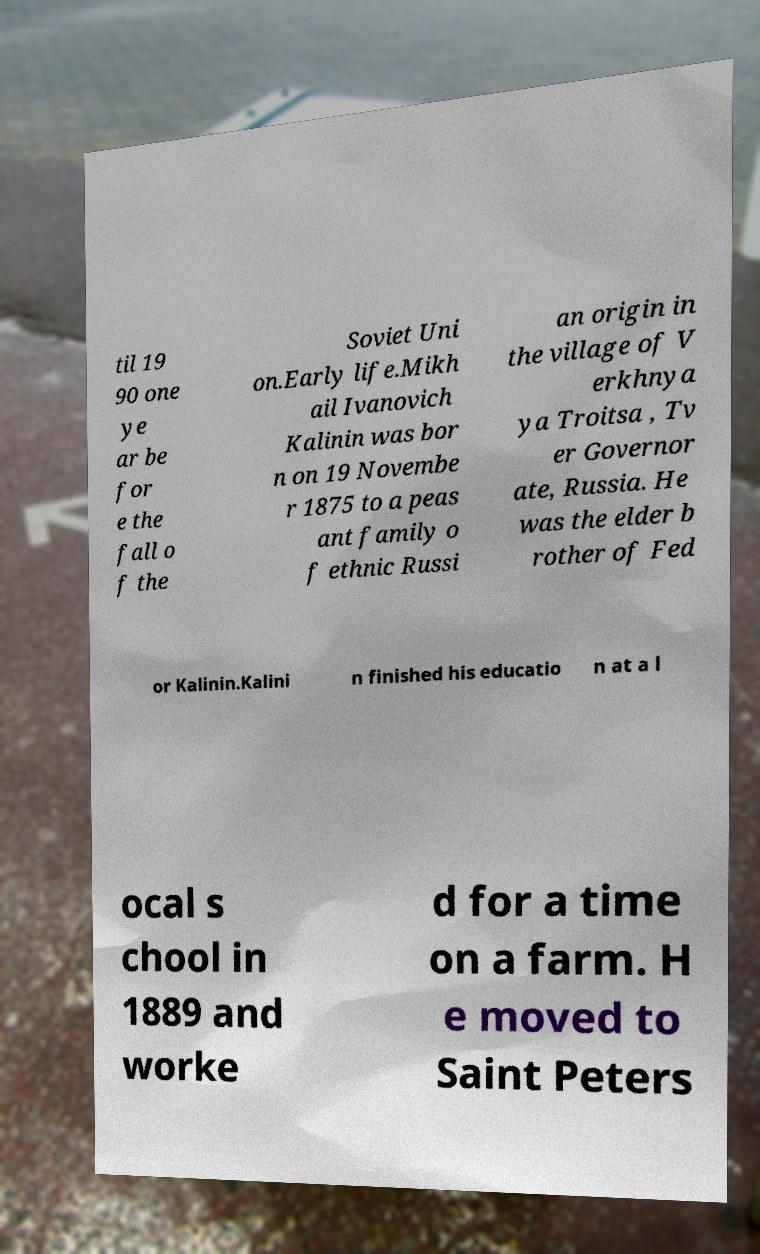Can you read and provide the text displayed in the image?This photo seems to have some interesting text. Can you extract and type it out for me? til 19 90 one ye ar be for e the fall o f the Soviet Uni on.Early life.Mikh ail Ivanovich Kalinin was bor n on 19 Novembe r 1875 to a peas ant family o f ethnic Russi an origin in the village of V erkhnya ya Troitsa , Tv er Governor ate, Russia. He was the elder b rother of Fed or Kalinin.Kalini n finished his educatio n at a l ocal s chool in 1889 and worke d for a time on a farm. H e moved to Saint Peters 